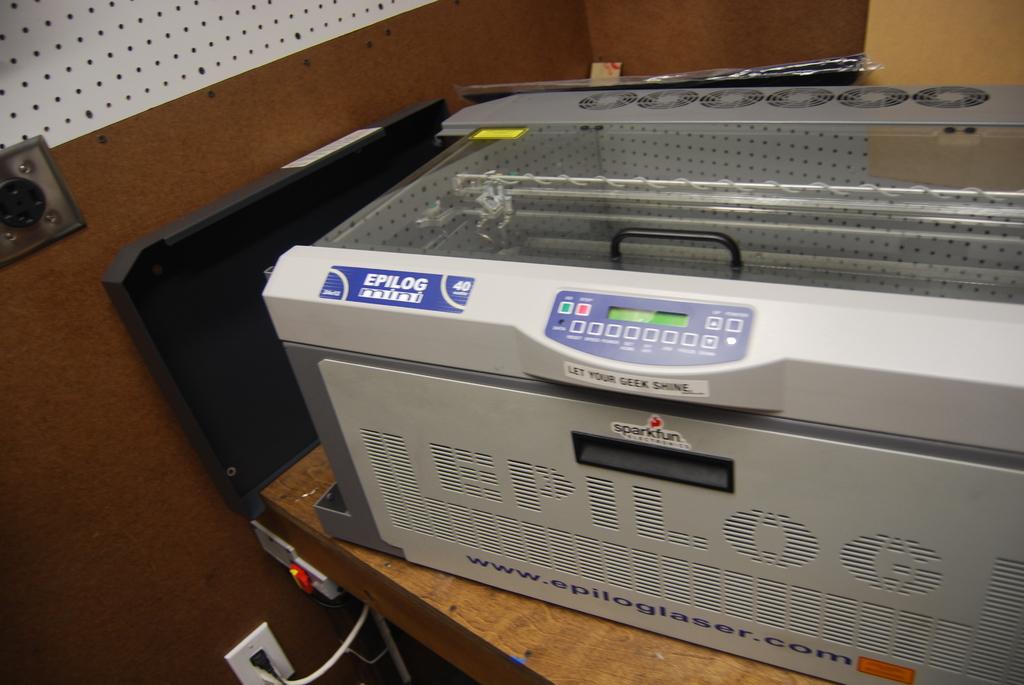What is the website shown on the machine?
Keep it short and to the point. Www.epiloglaser.com. What brand is this?
Ensure brevity in your answer.  Epilog. 